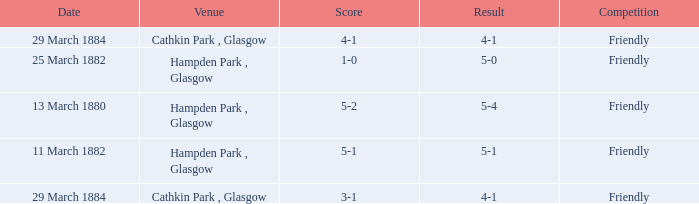Which item resulted in a score of 4-1? 3-1, 4-1. 